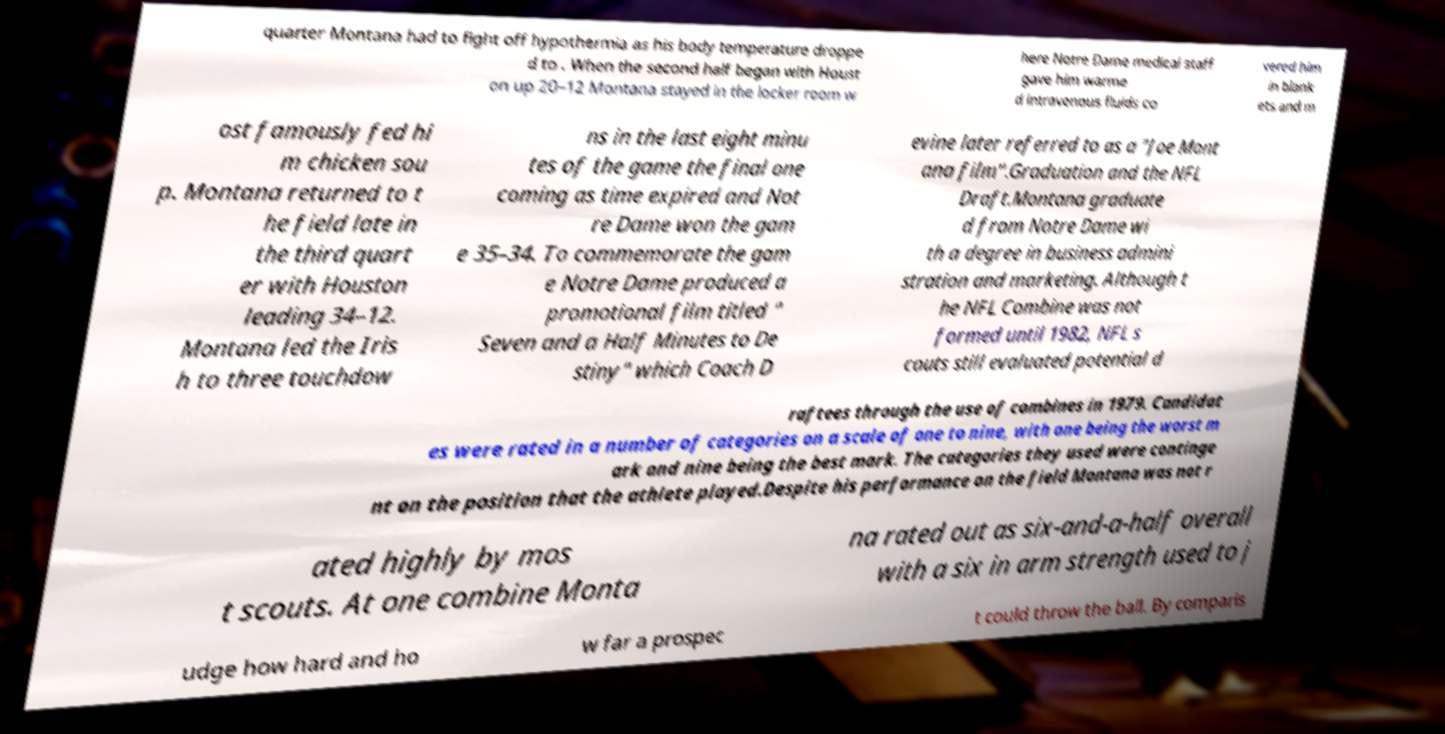Please identify and transcribe the text found in this image. quarter Montana had to fight off hypothermia as his body temperature droppe d to . When the second half began with Houst on up 20–12 Montana stayed in the locker room w here Notre Dame medical staff gave him warme d intravenous fluids co vered him in blank ets and m ost famously fed hi m chicken sou p. Montana returned to t he field late in the third quart er with Houston leading 34–12. Montana led the Iris h to three touchdow ns in the last eight minu tes of the game the final one coming as time expired and Not re Dame won the gam e 35–34. To commemorate the gam e Notre Dame produced a promotional film titled " Seven and a Half Minutes to De stiny" which Coach D evine later referred to as a "Joe Mont ana film".Graduation and the NFL Draft.Montana graduate d from Notre Dame wi th a degree in business admini stration and marketing. Although t he NFL Combine was not formed until 1982, NFL s couts still evaluated potential d raftees through the use of combines in 1979. Candidat es were rated in a number of categories on a scale of one to nine, with one being the worst m ark and nine being the best mark. The categories they used were continge nt on the position that the athlete played.Despite his performance on the field Montana was not r ated highly by mos t scouts. At one combine Monta na rated out as six-and-a-half overall with a six in arm strength used to j udge how hard and ho w far a prospec t could throw the ball. By comparis 